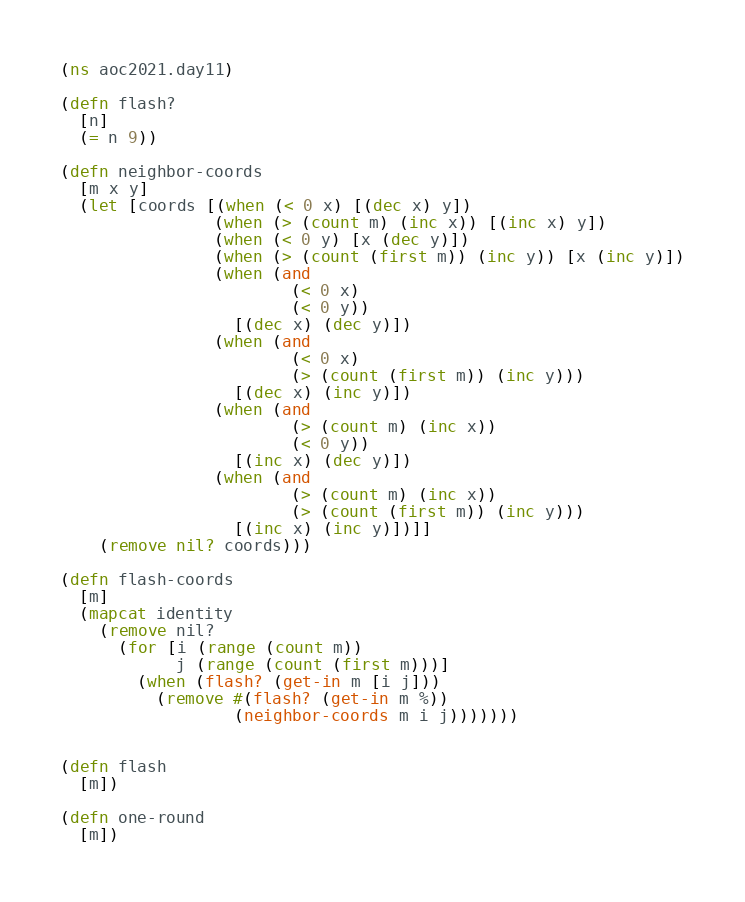<code> <loc_0><loc_0><loc_500><loc_500><_Clojure_>(ns aoc2021.day11)

(defn flash?
  [n]
  (= n 9))

(defn neighbor-coords
  [m x y]
  (let [coords [(when (< 0 x) [(dec x) y])
                (when (> (count m) (inc x)) [(inc x) y])
                (when (< 0 y) [x (dec y)])
                (when (> (count (first m)) (inc y)) [x (inc y)])
                (when (and
                        (< 0 x)
                        (< 0 y))
                  [(dec x) (dec y)])
                (when (and
                        (< 0 x)
                        (> (count (first m)) (inc y)))
                  [(dec x) (inc y)])
                (when (and
                        (> (count m) (inc x))
                        (< 0 y))
                  [(inc x) (dec y)])
                (when (and
                        (> (count m) (inc x))
                        (> (count (first m)) (inc y)))
                  [(inc x) (inc y)])]]
    (remove nil? coords)))

(defn flash-coords
  [m]
  (mapcat identity
    (remove nil?
      (for [i (range (count m))
            j (range (count (first m)))]
        (when (flash? (get-in m [i j]))
          (remove #(flash? (get-in m %))
                  (neighbor-coords m i j)))))))


(defn flash
  [m])

(defn one-round
  [m])

</code> 